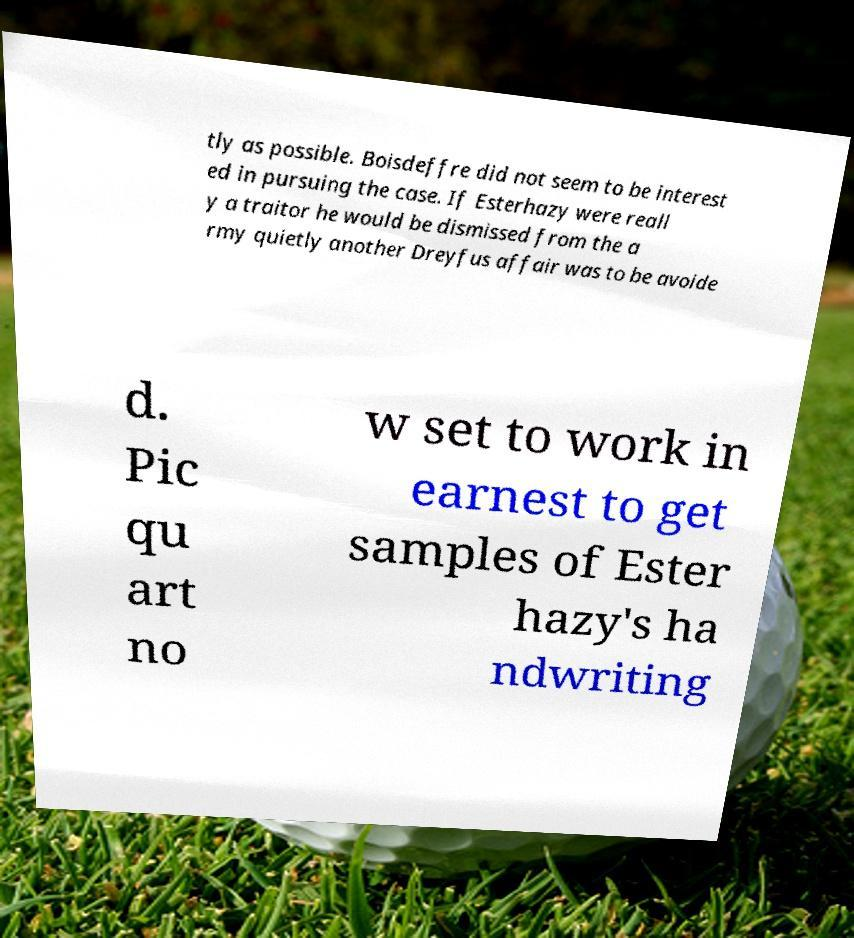Could you assist in decoding the text presented in this image and type it out clearly? tly as possible. Boisdeffre did not seem to be interest ed in pursuing the case. If Esterhazy were reall y a traitor he would be dismissed from the a rmy quietly another Dreyfus affair was to be avoide d. Pic qu art no w set to work in earnest to get samples of Ester hazy's ha ndwriting 